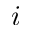Convert formula to latex. <formula><loc_0><loc_0><loc_500><loc_500>i</formula> 